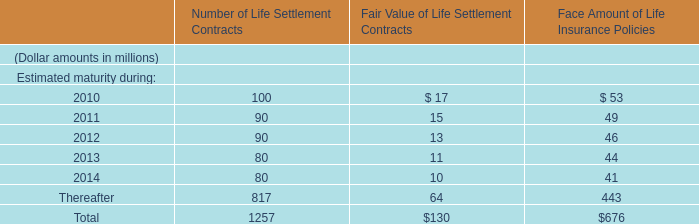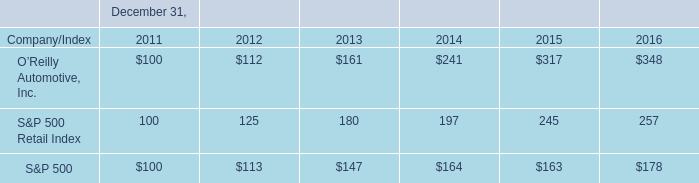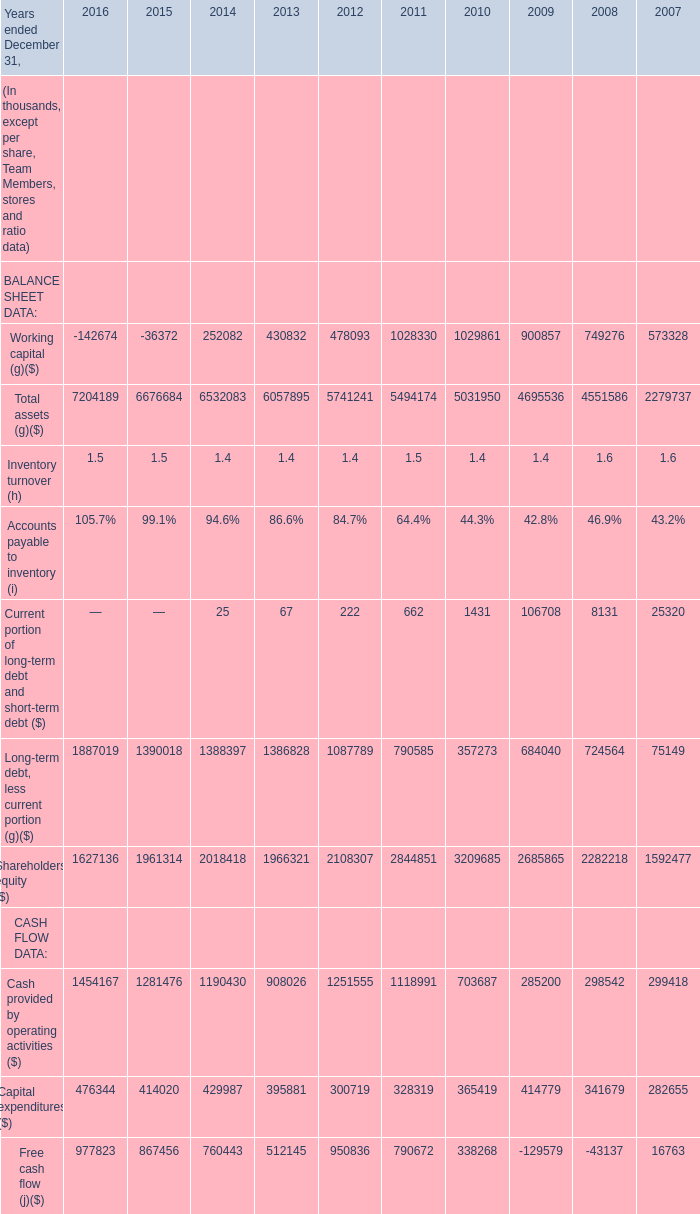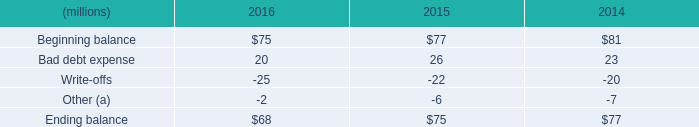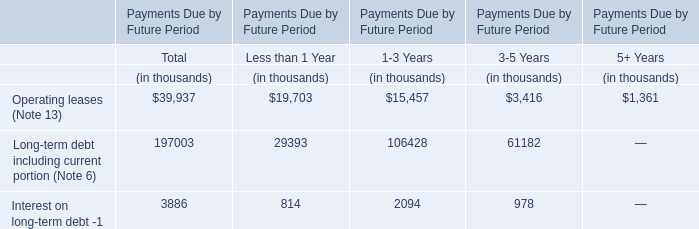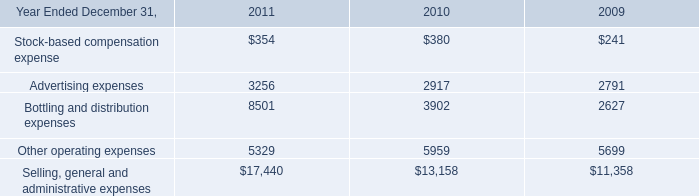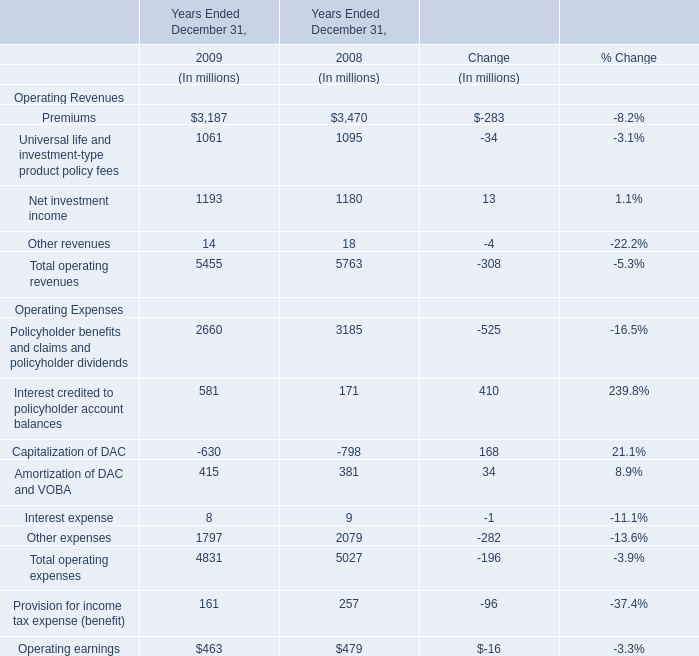If Cash provided by operating activities develops with the same growth rate in 2010, what will it reach in 2011? (in thousand) 
Computations: ((1 + ((703687 - 285200) / 285200)) * 703687)
Answer: 1736239.10929. 